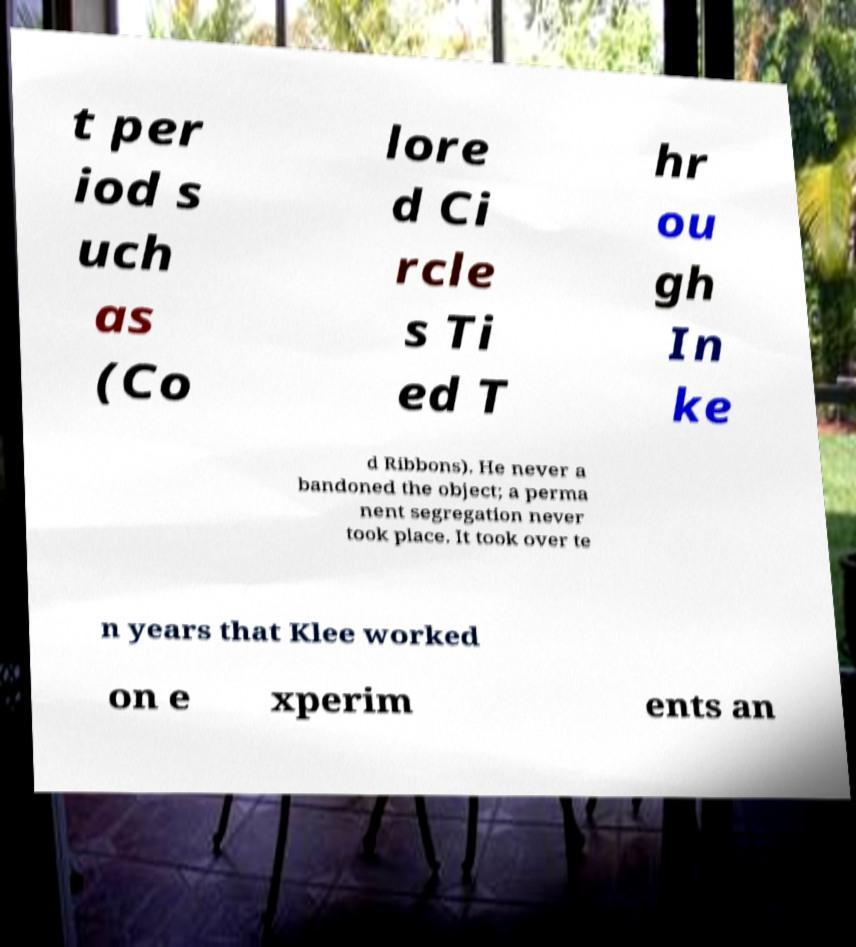Could you extract and type out the text from this image? t per iod s uch as (Co lore d Ci rcle s Ti ed T hr ou gh In ke d Ribbons). He never a bandoned the object; a perma nent segregation never took place. It took over te n years that Klee worked on e xperim ents an 